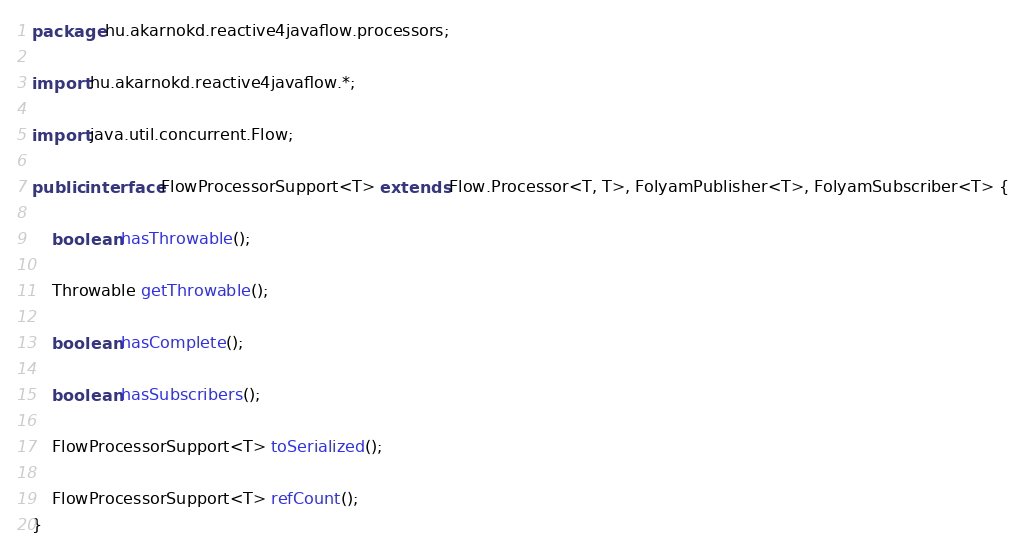Convert code to text. <code><loc_0><loc_0><loc_500><loc_500><_Java_>
package hu.akarnokd.reactive4javaflow.processors;

import hu.akarnokd.reactive4javaflow.*;

import java.util.concurrent.Flow;

public interface FlowProcessorSupport<T> extends Flow.Processor<T, T>, FolyamPublisher<T>, FolyamSubscriber<T> {

    boolean hasThrowable();

    Throwable getThrowable();

    boolean hasComplete();

    boolean hasSubscribers();

    FlowProcessorSupport<T> toSerialized();

    FlowProcessorSupport<T> refCount();
}
</code> 